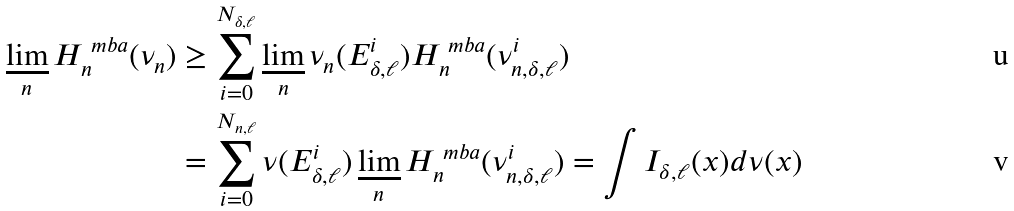Convert formula to latex. <formula><loc_0><loc_0><loc_500><loc_500>\varliminf _ { n } H _ { n } ^ { \ m b a } ( \nu _ { n } ) & \geq \sum _ { i = 0 } ^ { N _ { \delta , \ell } } \varliminf _ { n } \nu _ { n } ( E _ { \delta , \ell } ^ { i } ) H _ { n } ^ { \ m b a } ( \nu ^ { i } _ { n , \delta , \ell } ) \\ & = \sum _ { i = 0 } ^ { N _ { n , \ell } } \nu ( E _ { \delta , \ell } ^ { i } ) \varliminf _ { n } H _ { n } ^ { \ m b a } ( \nu ^ { i } _ { n , \delta , \ell } ) = \int I _ { \delta , \ell } ( x ) d \nu ( x )</formula> 